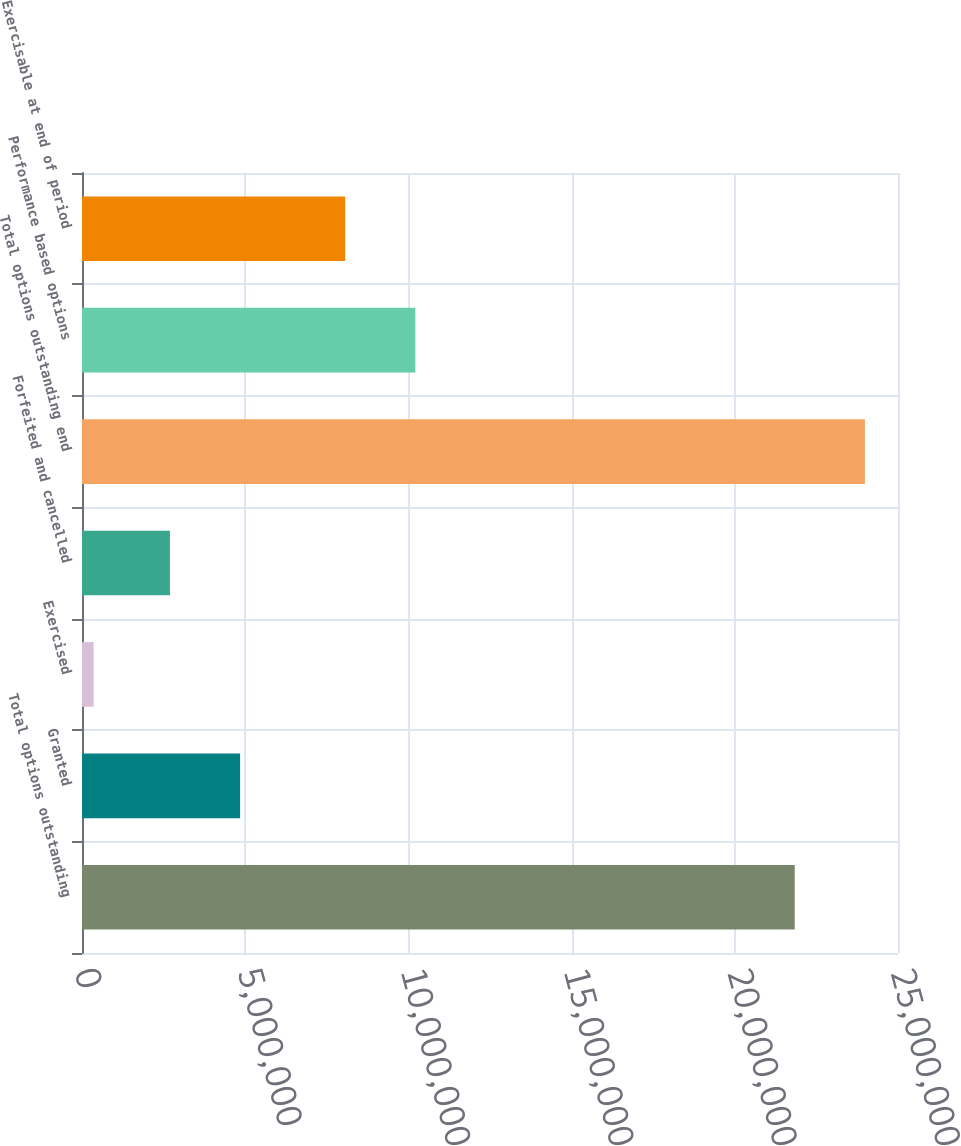Convert chart. <chart><loc_0><loc_0><loc_500><loc_500><bar_chart><fcel>Total options outstanding<fcel>Granted<fcel>Exercised<fcel>Forfeited and cancelled<fcel>Total options outstanding end<fcel>Performance based options<fcel>Exercisable at end of period<nl><fcel>2.18357e+07<fcel>4.84469e+06<fcel>356793<fcel>2.6942e+06<fcel>2.39862e+07<fcel>1.02126e+07<fcel>8.06209e+06<nl></chart> 